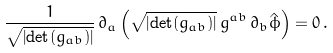Convert formula to latex. <formula><loc_0><loc_0><loc_500><loc_500>\frac { 1 } { \sqrt { \left | \det ( g _ { a b } ) \right | } } \, \partial _ { a } \left ( \sqrt { \left | \det ( g _ { a b } ) \right | } \, g ^ { a b } \, \partial _ { b } \hat { \phi } \right ) = 0 \, . \\</formula> 